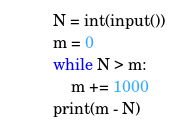Convert code to text. <code><loc_0><loc_0><loc_500><loc_500><_Python_>N = int(input())
m = 0
while N > m:
    m += 1000
print(m - N)
</code> 